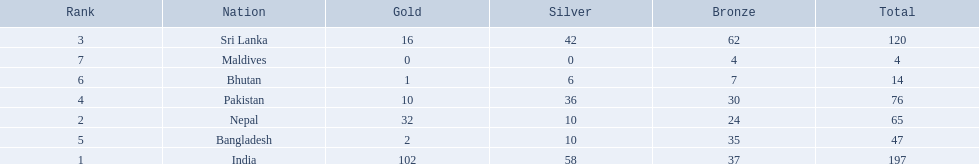What are all the countries listed in the table? India, Nepal, Sri Lanka, Pakistan, Bangladesh, Bhutan, Maldives. Which of these is not india? Nepal, Sri Lanka, Pakistan, Bangladesh, Bhutan, Maldives. Of these, which is first? Nepal. 